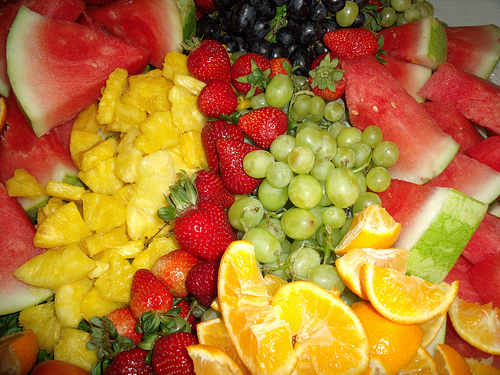<image>
Is there a strawberries in front of the oranges? No. The strawberries is not in front of the oranges. The spatial positioning shows a different relationship between these objects. 